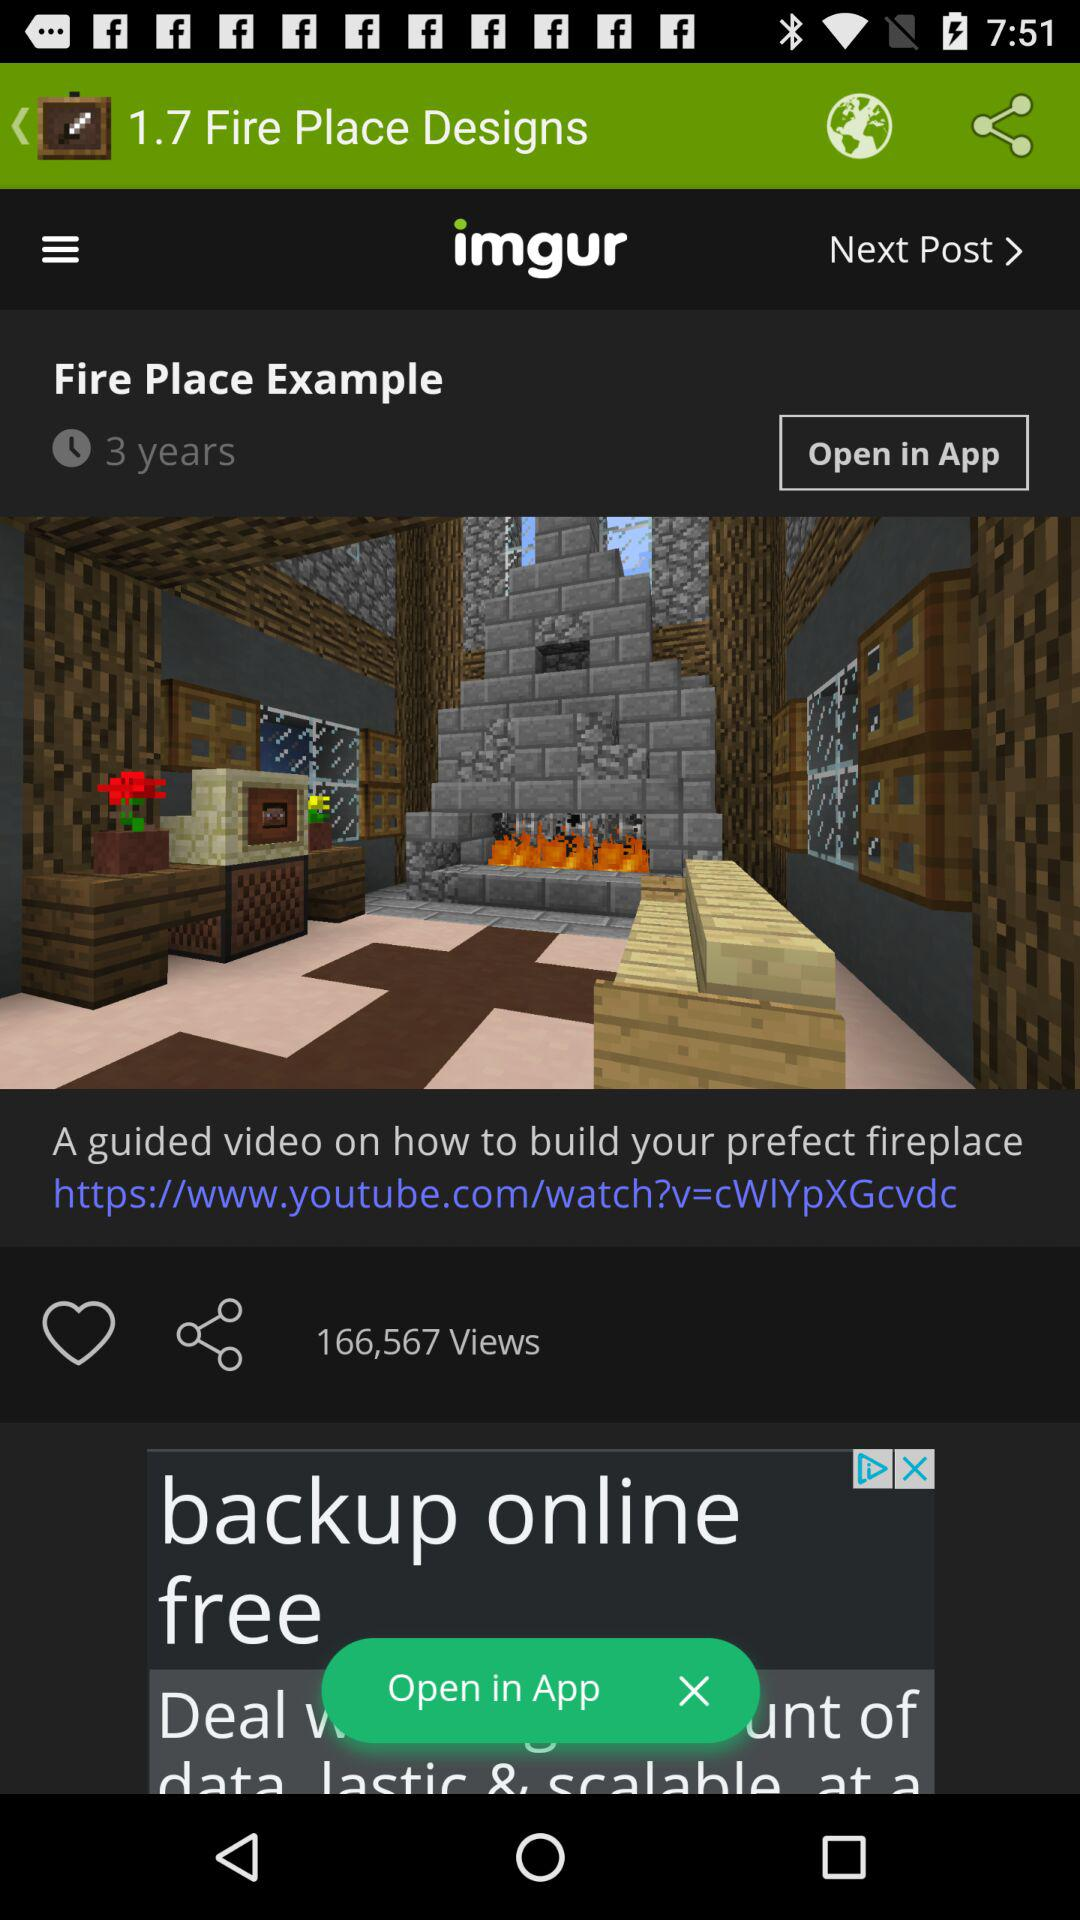What is the duration given?
When the provided information is insufficient, respond with <no answer>. <no answer> 